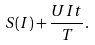Convert formula to latex. <formula><loc_0><loc_0><loc_500><loc_500>S ( I ) + \frac { U I t } { T } .</formula> 